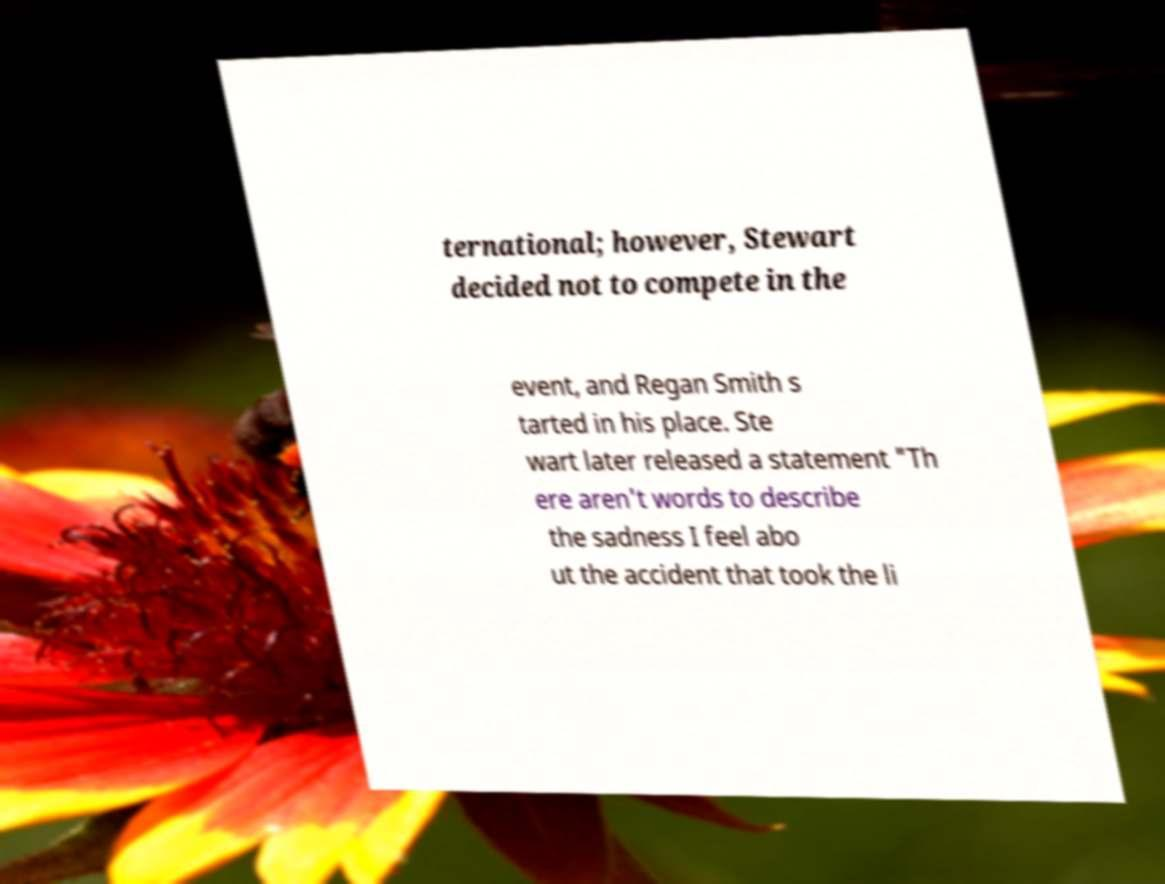Could you assist in decoding the text presented in this image and type it out clearly? ternational; however, Stewart decided not to compete in the event, and Regan Smith s tarted in his place. Ste wart later released a statement "Th ere aren't words to describe the sadness I feel abo ut the accident that took the li 